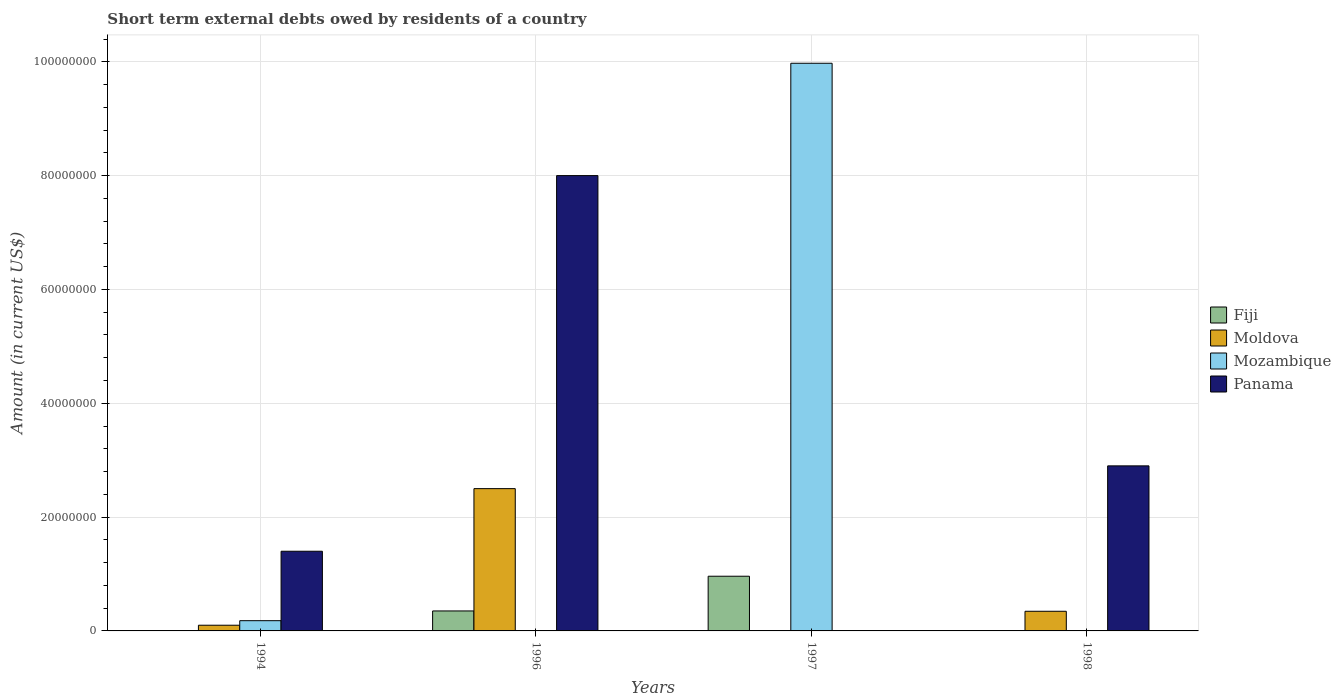How many different coloured bars are there?
Your response must be concise. 4. How many groups of bars are there?
Your answer should be compact. 4. What is the label of the 2nd group of bars from the left?
Give a very brief answer. 1996. What is the amount of short-term external debts owed by residents in Moldova in 1997?
Your response must be concise. 0. Across all years, what is the maximum amount of short-term external debts owed by residents in Mozambique?
Keep it short and to the point. 9.97e+07. What is the total amount of short-term external debts owed by residents in Moldova in the graph?
Offer a very short reply. 2.95e+07. What is the difference between the amount of short-term external debts owed by residents in Fiji in 1996 and that in 1997?
Make the answer very short. -6.10e+06. What is the difference between the amount of short-term external debts owed by residents in Moldova in 1998 and the amount of short-term external debts owed by residents in Fiji in 1994?
Ensure brevity in your answer.  3.45e+06. What is the average amount of short-term external debts owed by residents in Panama per year?
Your response must be concise. 3.08e+07. In the year 1997, what is the difference between the amount of short-term external debts owed by residents in Mozambique and amount of short-term external debts owed by residents in Fiji?
Your answer should be compact. 9.01e+07. In how many years, is the amount of short-term external debts owed by residents in Fiji greater than 48000000 US$?
Offer a very short reply. 0. What is the ratio of the amount of short-term external debts owed by residents in Moldova in 1996 to that in 1998?
Offer a very short reply. 7.24. Is the amount of short-term external debts owed by residents in Panama in 1996 less than that in 1998?
Provide a succinct answer. No. What is the difference between the highest and the second highest amount of short-term external debts owed by residents in Panama?
Provide a short and direct response. 5.10e+07. What is the difference between the highest and the lowest amount of short-term external debts owed by residents in Moldova?
Ensure brevity in your answer.  2.50e+07. In how many years, is the amount of short-term external debts owed by residents in Panama greater than the average amount of short-term external debts owed by residents in Panama taken over all years?
Your answer should be very brief. 1. Is it the case that in every year, the sum of the amount of short-term external debts owed by residents in Panama and amount of short-term external debts owed by residents in Mozambique is greater than the sum of amount of short-term external debts owed by residents in Moldova and amount of short-term external debts owed by residents in Fiji?
Provide a succinct answer. Yes. Is it the case that in every year, the sum of the amount of short-term external debts owed by residents in Moldova and amount of short-term external debts owed by residents in Fiji is greater than the amount of short-term external debts owed by residents in Panama?
Offer a very short reply. No. How many bars are there?
Give a very brief answer. 10. Are all the bars in the graph horizontal?
Make the answer very short. No. What is the difference between two consecutive major ticks on the Y-axis?
Keep it short and to the point. 2.00e+07. Does the graph contain any zero values?
Offer a very short reply. Yes. Does the graph contain grids?
Offer a terse response. Yes. Where does the legend appear in the graph?
Give a very brief answer. Center right. How are the legend labels stacked?
Make the answer very short. Vertical. What is the title of the graph?
Your answer should be compact. Short term external debts owed by residents of a country. Does "Puerto Rico" appear as one of the legend labels in the graph?
Make the answer very short. No. What is the Amount (in current US$) in Fiji in 1994?
Keep it short and to the point. 0. What is the Amount (in current US$) in Moldova in 1994?
Your answer should be compact. 1.00e+06. What is the Amount (in current US$) of Mozambique in 1994?
Give a very brief answer. 1.80e+06. What is the Amount (in current US$) of Panama in 1994?
Offer a very short reply. 1.40e+07. What is the Amount (in current US$) of Fiji in 1996?
Your answer should be compact. 3.51e+06. What is the Amount (in current US$) of Moldova in 1996?
Offer a terse response. 2.50e+07. What is the Amount (in current US$) in Mozambique in 1996?
Make the answer very short. 0. What is the Amount (in current US$) in Panama in 1996?
Make the answer very short. 8.00e+07. What is the Amount (in current US$) in Fiji in 1997?
Provide a short and direct response. 9.61e+06. What is the Amount (in current US$) in Moldova in 1997?
Offer a very short reply. 0. What is the Amount (in current US$) in Mozambique in 1997?
Make the answer very short. 9.97e+07. What is the Amount (in current US$) in Moldova in 1998?
Keep it short and to the point. 3.45e+06. What is the Amount (in current US$) of Panama in 1998?
Keep it short and to the point. 2.90e+07. Across all years, what is the maximum Amount (in current US$) of Fiji?
Your answer should be compact. 9.61e+06. Across all years, what is the maximum Amount (in current US$) of Moldova?
Give a very brief answer. 2.50e+07. Across all years, what is the maximum Amount (in current US$) of Mozambique?
Your response must be concise. 9.97e+07. Across all years, what is the maximum Amount (in current US$) in Panama?
Provide a short and direct response. 8.00e+07. Across all years, what is the minimum Amount (in current US$) of Fiji?
Your response must be concise. 0. What is the total Amount (in current US$) of Fiji in the graph?
Ensure brevity in your answer.  1.31e+07. What is the total Amount (in current US$) of Moldova in the graph?
Keep it short and to the point. 2.95e+07. What is the total Amount (in current US$) in Mozambique in the graph?
Ensure brevity in your answer.  1.02e+08. What is the total Amount (in current US$) in Panama in the graph?
Provide a succinct answer. 1.23e+08. What is the difference between the Amount (in current US$) of Moldova in 1994 and that in 1996?
Offer a very short reply. -2.40e+07. What is the difference between the Amount (in current US$) of Panama in 1994 and that in 1996?
Your answer should be very brief. -6.60e+07. What is the difference between the Amount (in current US$) of Mozambique in 1994 and that in 1997?
Ensure brevity in your answer.  -9.79e+07. What is the difference between the Amount (in current US$) of Moldova in 1994 and that in 1998?
Give a very brief answer. -2.45e+06. What is the difference between the Amount (in current US$) in Panama in 1994 and that in 1998?
Provide a succinct answer. -1.50e+07. What is the difference between the Amount (in current US$) in Fiji in 1996 and that in 1997?
Make the answer very short. -6.10e+06. What is the difference between the Amount (in current US$) in Moldova in 1996 and that in 1998?
Make the answer very short. 2.15e+07. What is the difference between the Amount (in current US$) in Panama in 1996 and that in 1998?
Provide a succinct answer. 5.10e+07. What is the difference between the Amount (in current US$) of Moldova in 1994 and the Amount (in current US$) of Panama in 1996?
Your answer should be compact. -7.90e+07. What is the difference between the Amount (in current US$) of Mozambique in 1994 and the Amount (in current US$) of Panama in 1996?
Your answer should be compact. -7.82e+07. What is the difference between the Amount (in current US$) in Moldova in 1994 and the Amount (in current US$) in Mozambique in 1997?
Your answer should be very brief. -9.87e+07. What is the difference between the Amount (in current US$) of Moldova in 1994 and the Amount (in current US$) of Panama in 1998?
Give a very brief answer. -2.80e+07. What is the difference between the Amount (in current US$) of Mozambique in 1994 and the Amount (in current US$) of Panama in 1998?
Offer a very short reply. -2.72e+07. What is the difference between the Amount (in current US$) in Fiji in 1996 and the Amount (in current US$) in Mozambique in 1997?
Keep it short and to the point. -9.62e+07. What is the difference between the Amount (in current US$) of Moldova in 1996 and the Amount (in current US$) of Mozambique in 1997?
Offer a terse response. -7.47e+07. What is the difference between the Amount (in current US$) in Fiji in 1996 and the Amount (in current US$) in Moldova in 1998?
Your answer should be compact. 5.70e+04. What is the difference between the Amount (in current US$) of Fiji in 1996 and the Amount (in current US$) of Panama in 1998?
Offer a very short reply. -2.55e+07. What is the difference between the Amount (in current US$) of Moldova in 1996 and the Amount (in current US$) of Panama in 1998?
Your answer should be very brief. -4.00e+06. What is the difference between the Amount (in current US$) of Fiji in 1997 and the Amount (in current US$) of Moldova in 1998?
Offer a terse response. 6.16e+06. What is the difference between the Amount (in current US$) in Fiji in 1997 and the Amount (in current US$) in Panama in 1998?
Provide a short and direct response. -1.94e+07. What is the difference between the Amount (in current US$) of Mozambique in 1997 and the Amount (in current US$) of Panama in 1998?
Your answer should be very brief. 7.07e+07. What is the average Amount (in current US$) of Fiji per year?
Offer a very short reply. 3.28e+06. What is the average Amount (in current US$) in Moldova per year?
Keep it short and to the point. 7.36e+06. What is the average Amount (in current US$) in Mozambique per year?
Offer a very short reply. 2.54e+07. What is the average Amount (in current US$) of Panama per year?
Your answer should be very brief. 3.08e+07. In the year 1994, what is the difference between the Amount (in current US$) of Moldova and Amount (in current US$) of Mozambique?
Make the answer very short. -8.00e+05. In the year 1994, what is the difference between the Amount (in current US$) in Moldova and Amount (in current US$) in Panama?
Your answer should be compact. -1.30e+07. In the year 1994, what is the difference between the Amount (in current US$) in Mozambique and Amount (in current US$) in Panama?
Offer a very short reply. -1.22e+07. In the year 1996, what is the difference between the Amount (in current US$) of Fiji and Amount (in current US$) of Moldova?
Your response must be concise. -2.15e+07. In the year 1996, what is the difference between the Amount (in current US$) of Fiji and Amount (in current US$) of Panama?
Offer a terse response. -7.65e+07. In the year 1996, what is the difference between the Amount (in current US$) in Moldova and Amount (in current US$) in Panama?
Keep it short and to the point. -5.50e+07. In the year 1997, what is the difference between the Amount (in current US$) of Fiji and Amount (in current US$) of Mozambique?
Your answer should be very brief. -9.01e+07. In the year 1998, what is the difference between the Amount (in current US$) in Moldova and Amount (in current US$) in Panama?
Keep it short and to the point. -2.55e+07. What is the ratio of the Amount (in current US$) of Panama in 1994 to that in 1996?
Make the answer very short. 0.17. What is the ratio of the Amount (in current US$) in Mozambique in 1994 to that in 1997?
Provide a short and direct response. 0.02. What is the ratio of the Amount (in current US$) in Moldova in 1994 to that in 1998?
Provide a succinct answer. 0.29. What is the ratio of the Amount (in current US$) of Panama in 1994 to that in 1998?
Ensure brevity in your answer.  0.48. What is the ratio of the Amount (in current US$) of Fiji in 1996 to that in 1997?
Your answer should be compact. 0.37. What is the ratio of the Amount (in current US$) in Moldova in 1996 to that in 1998?
Offer a very short reply. 7.24. What is the ratio of the Amount (in current US$) of Panama in 1996 to that in 1998?
Provide a succinct answer. 2.76. What is the difference between the highest and the second highest Amount (in current US$) of Moldova?
Your response must be concise. 2.15e+07. What is the difference between the highest and the second highest Amount (in current US$) in Panama?
Keep it short and to the point. 5.10e+07. What is the difference between the highest and the lowest Amount (in current US$) in Fiji?
Make the answer very short. 9.61e+06. What is the difference between the highest and the lowest Amount (in current US$) of Moldova?
Keep it short and to the point. 2.50e+07. What is the difference between the highest and the lowest Amount (in current US$) of Mozambique?
Ensure brevity in your answer.  9.97e+07. What is the difference between the highest and the lowest Amount (in current US$) of Panama?
Your response must be concise. 8.00e+07. 